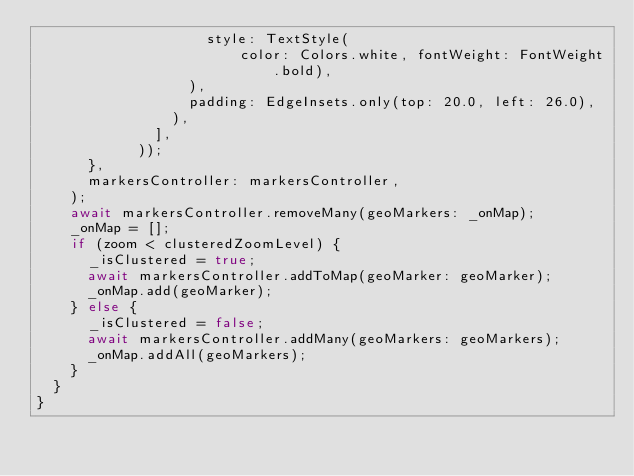Convert code to text. <code><loc_0><loc_0><loc_500><loc_500><_Dart_>                    style: TextStyle(
                        color: Colors.white, fontWeight: FontWeight.bold),
                  ),
                  padding: EdgeInsets.only(top: 20.0, left: 26.0),
                ),
              ],
            ));
      },
      markersController: markersController,
    );
    await markersController.removeMany(geoMarkers: _onMap);
    _onMap = [];
    if (zoom < clusteredZoomLevel) {
      _isClustered = true;
      await markersController.addToMap(geoMarker: geoMarker);
      _onMap.add(geoMarker);
    } else {
      _isClustered = false;
      await markersController.addMany(geoMarkers: geoMarkers);
      _onMap.addAll(geoMarkers);
    }
  }
}
</code> 